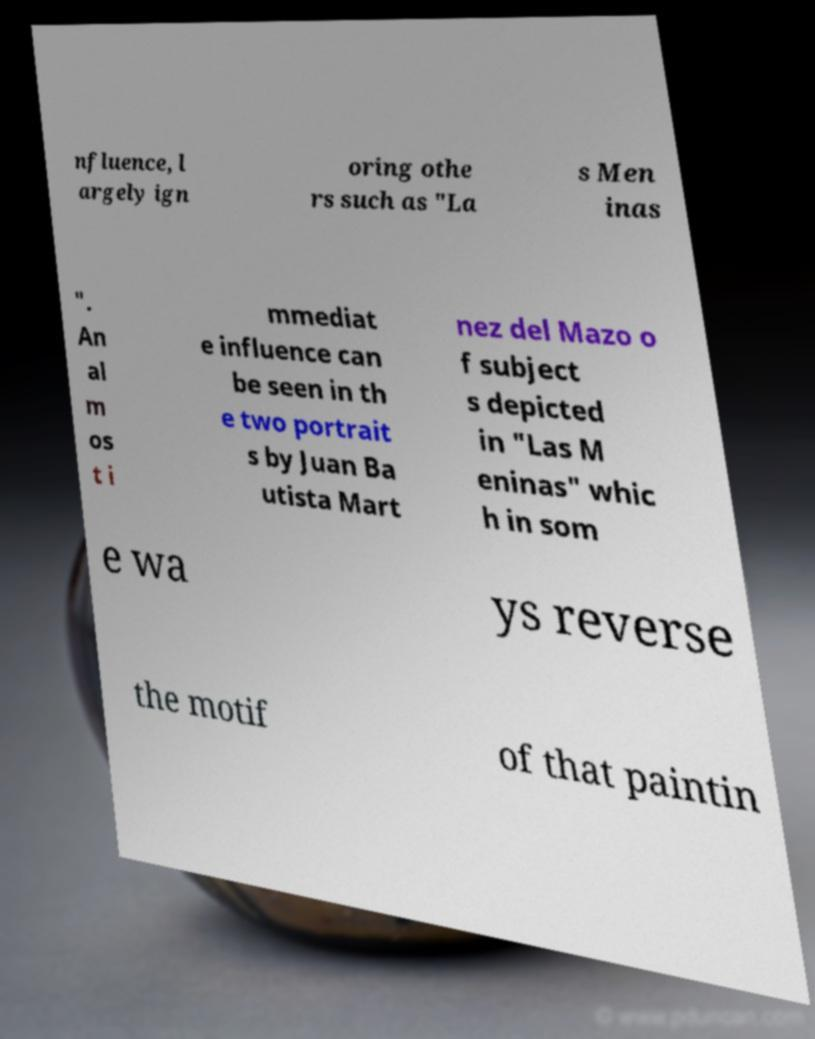Please identify and transcribe the text found in this image. nfluence, l argely ign oring othe rs such as "La s Men inas ". An al m os t i mmediat e influence can be seen in th e two portrait s by Juan Ba utista Mart nez del Mazo o f subject s depicted in "Las M eninas" whic h in som e wa ys reverse the motif of that paintin 